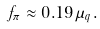Convert formula to latex. <formula><loc_0><loc_0><loc_500><loc_500>f _ { \pi } \approx 0 . 1 9 \mu _ { q } .</formula> 